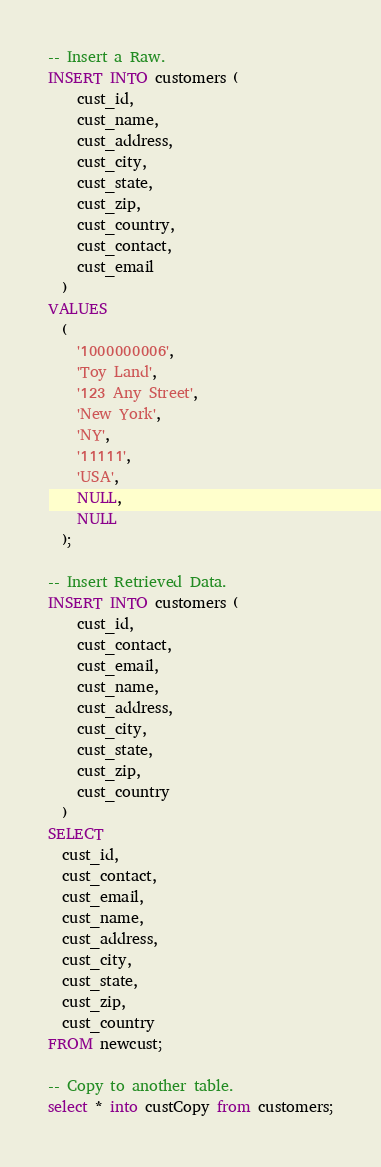<code> <loc_0><loc_0><loc_500><loc_500><_SQL_>-- Insert a Raw.
INSERT INTO customers (
    cust_id,
    cust_name,
    cust_address,
    cust_city,
    cust_state,
    cust_zip,
    cust_country,
    cust_contact,
    cust_email
  )
VALUES
  (
    '1000000006',
    'Toy Land',
    '123 Any Street',
    'New York',
    'NY',
    '11111',
    'USA',
    NULL,
    NULL
  );

-- Insert Retrieved Data.
INSERT INTO customers (
    cust_id,
    cust_contact,
    cust_email,
    cust_name,
    cust_address,
    cust_city,
    cust_state,
    cust_zip,
    cust_country
  )
SELECT
  cust_id,
  cust_contact,
  cust_email,
  cust_name,
  cust_address,
  cust_city,
  cust_state,
  cust_zip,
  cust_country
FROM newcust;

-- Copy to another table.
select * into custCopy from customers;</code> 